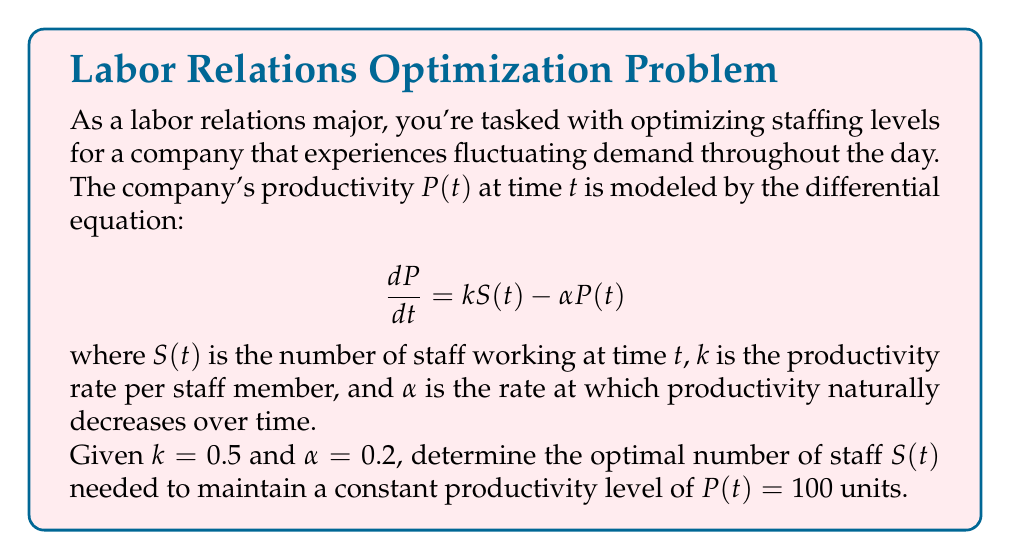Help me with this question. Let's approach this step-by-step:

1) We want to maintain a constant productivity level, which means $\frac{dP}{dt} = 0$. So we can set our equation to zero:

   $$0 = kS(t) - \alpha P(t)$$

2) We're given that $k = 0.5$, $\alpha = 0.2$, and we want $P(t) = 100$. Let's substitute these values:

   $$0 = 0.5S(t) - 0.2(100)$$

3) Simplify the right side:

   $$0 = 0.5S(t) - 20$$

4) Add 20 to both sides:

   $$20 = 0.5S(t)$$

5) Multiply both sides by 2 to isolate $S(t)$:

   $$40 = S(t)$$

Therefore, to maintain a constant productivity level of 100 units, the company needs to maintain a constant staffing level of 40 employees.
Answer: $S(t) = 40$ employees 